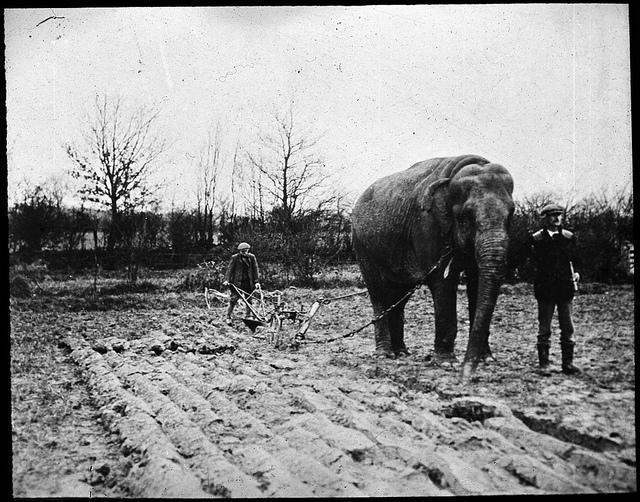How many people can you see?
Give a very brief answer. 1. How many chairs are there?
Give a very brief answer. 0. 